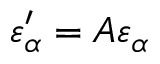Convert formula to latex. <formula><loc_0><loc_0><loc_500><loc_500>\varepsilon _ { \alpha } ^ { \prime } = A \varepsilon _ { \alpha }</formula> 